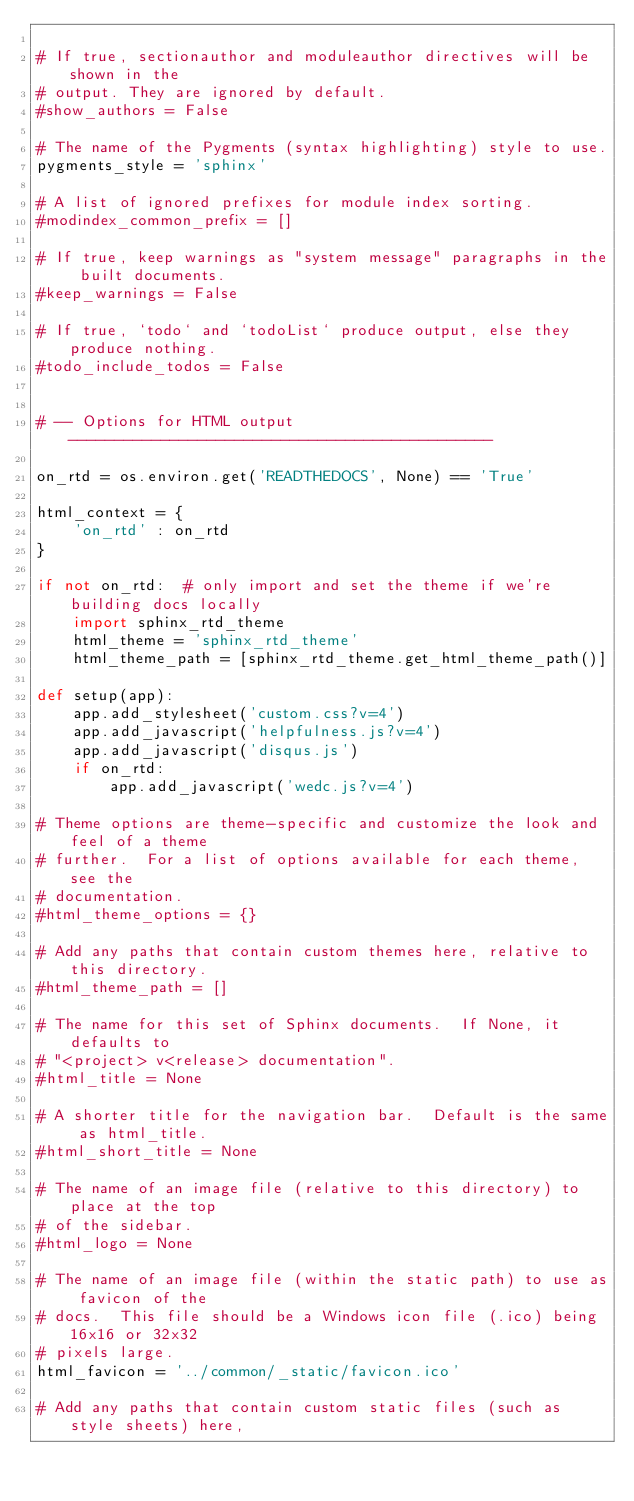<code> <loc_0><loc_0><loc_500><loc_500><_Python_>
# If true, sectionauthor and moduleauthor directives will be shown in the
# output. They are ignored by default.
#show_authors = False

# The name of the Pygments (syntax highlighting) style to use.
pygments_style = 'sphinx'

# A list of ignored prefixes for module index sorting.
#modindex_common_prefix = []

# If true, keep warnings as "system message" paragraphs in the built documents.
#keep_warnings = False

# If true, `todo` and `todoList` produce output, else they produce nothing.
#todo_include_todos = False


# -- Options for HTML output ----------------------------------------------

on_rtd = os.environ.get('READTHEDOCS', None) == 'True'

html_context = {
    'on_rtd' : on_rtd
}

if not on_rtd:  # only import and set the theme if we're building docs locally
    import sphinx_rtd_theme
    html_theme = 'sphinx_rtd_theme'
    html_theme_path = [sphinx_rtd_theme.get_html_theme_path()]

def setup(app):
    app.add_stylesheet('custom.css?v=4')
    app.add_javascript('helpfulness.js?v=4')
    app.add_javascript('disqus.js')
    if on_rtd:
        app.add_javascript('wedc.js?v=4')

# Theme options are theme-specific and customize the look and feel of a theme
# further.  For a list of options available for each theme, see the
# documentation.
#html_theme_options = {}

# Add any paths that contain custom themes here, relative to this directory.
#html_theme_path = []

# The name for this set of Sphinx documents.  If None, it defaults to
# "<project> v<release> documentation".
#html_title = None

# A shorter title for the navigation bar.  Default is the same as html_title.
#html_short_title = None

# The name of an image file (relative to this directory) to place at the top
# of the sidebar.
#html_logo = None

# The name of an image file (within the static path) to use as favicon of the
# docs.  This file should be a Windows icon file (.ico) being 16x16 or 32x32
# pixels large.
html_favicon = '../common/_static/favicon.ico'

# Add any paths that contain custom static files (such as style sheets) here,</code> 